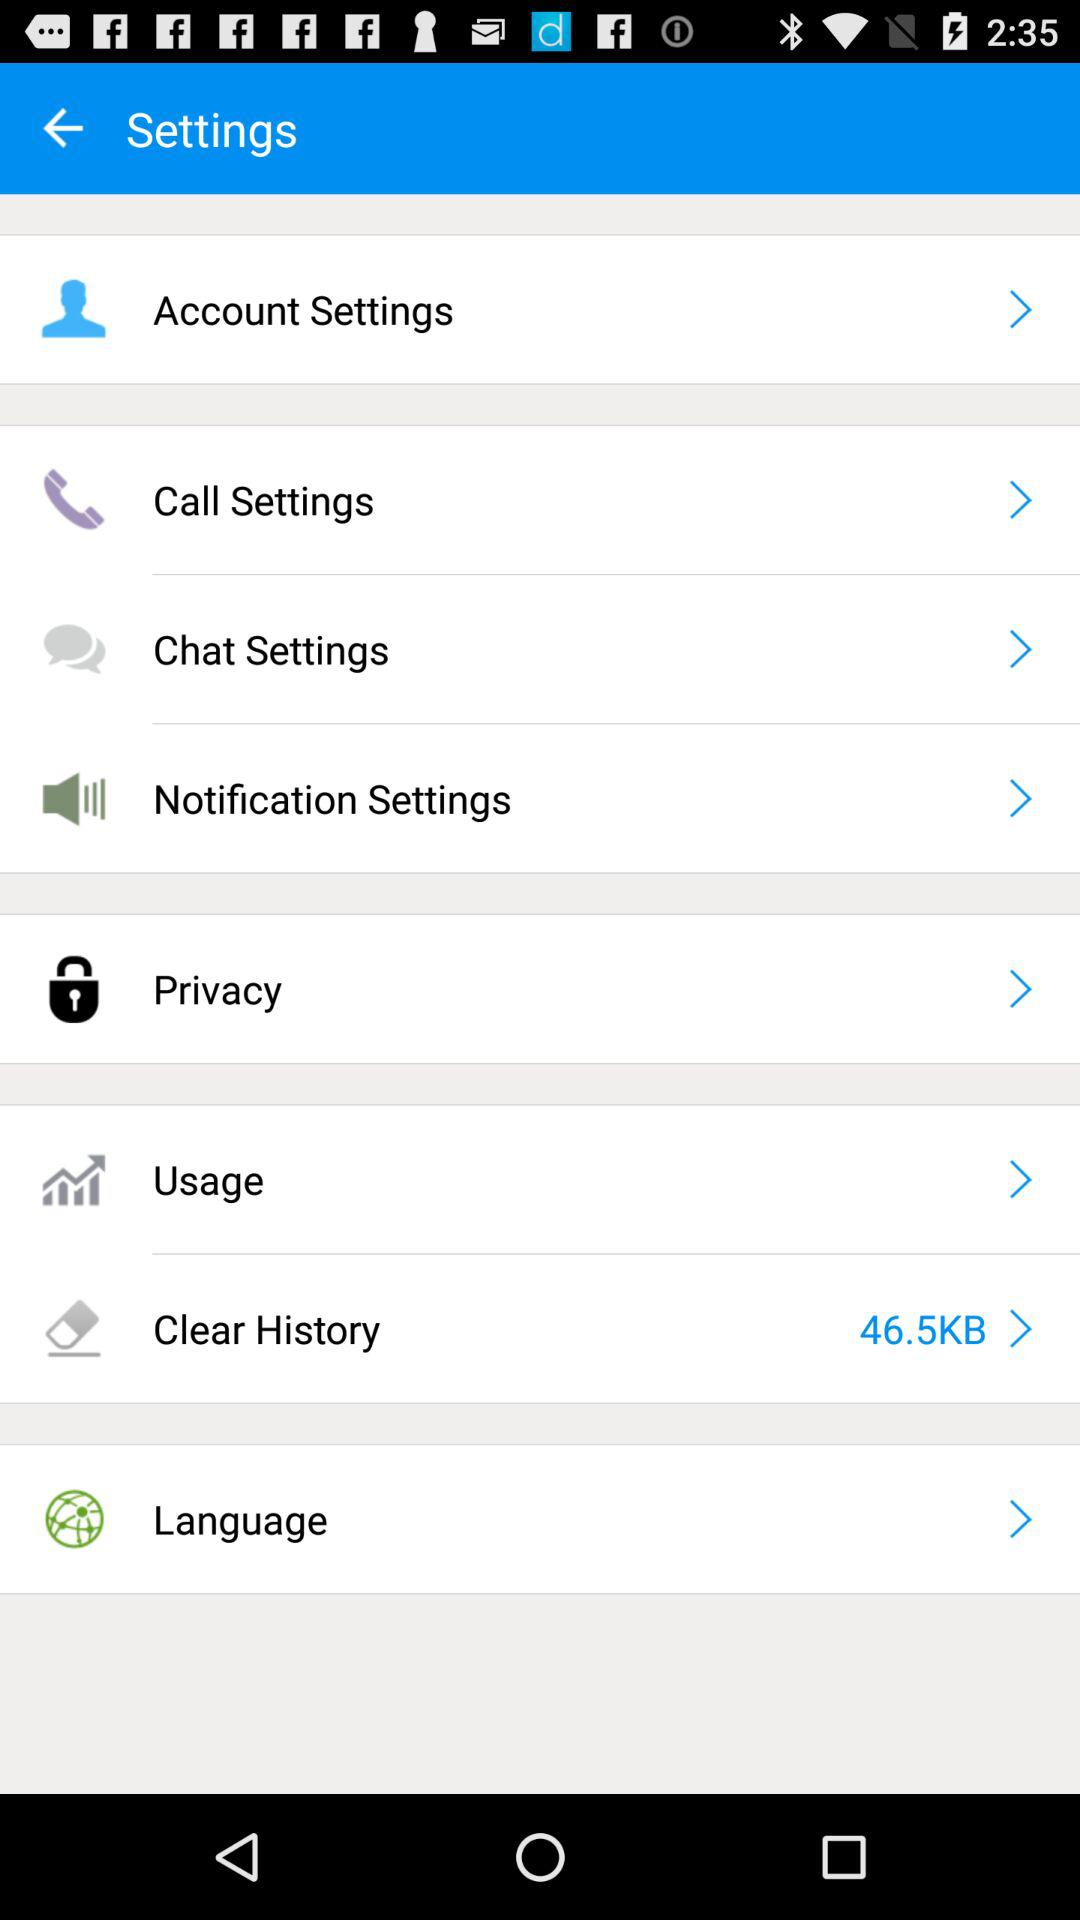How much KB is in "Clear History"? There are 46.5 KB in "Clear History". 